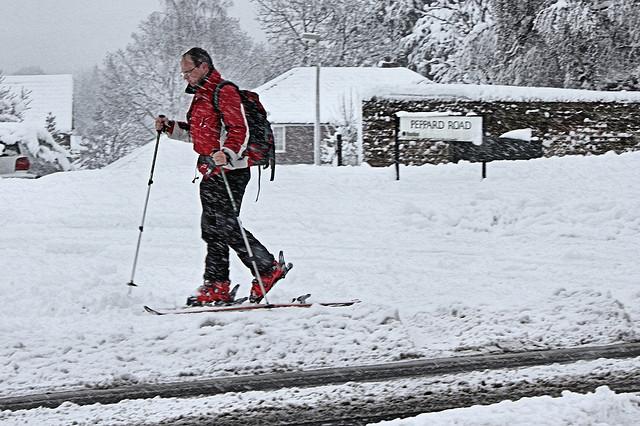Are there any tire tracks?
Quick response, please. Yes. What is the guy doing?
Give a very brief answer. Skiing. What is the person doing on the skis? in the snow?
Concise answer only. Walking. 